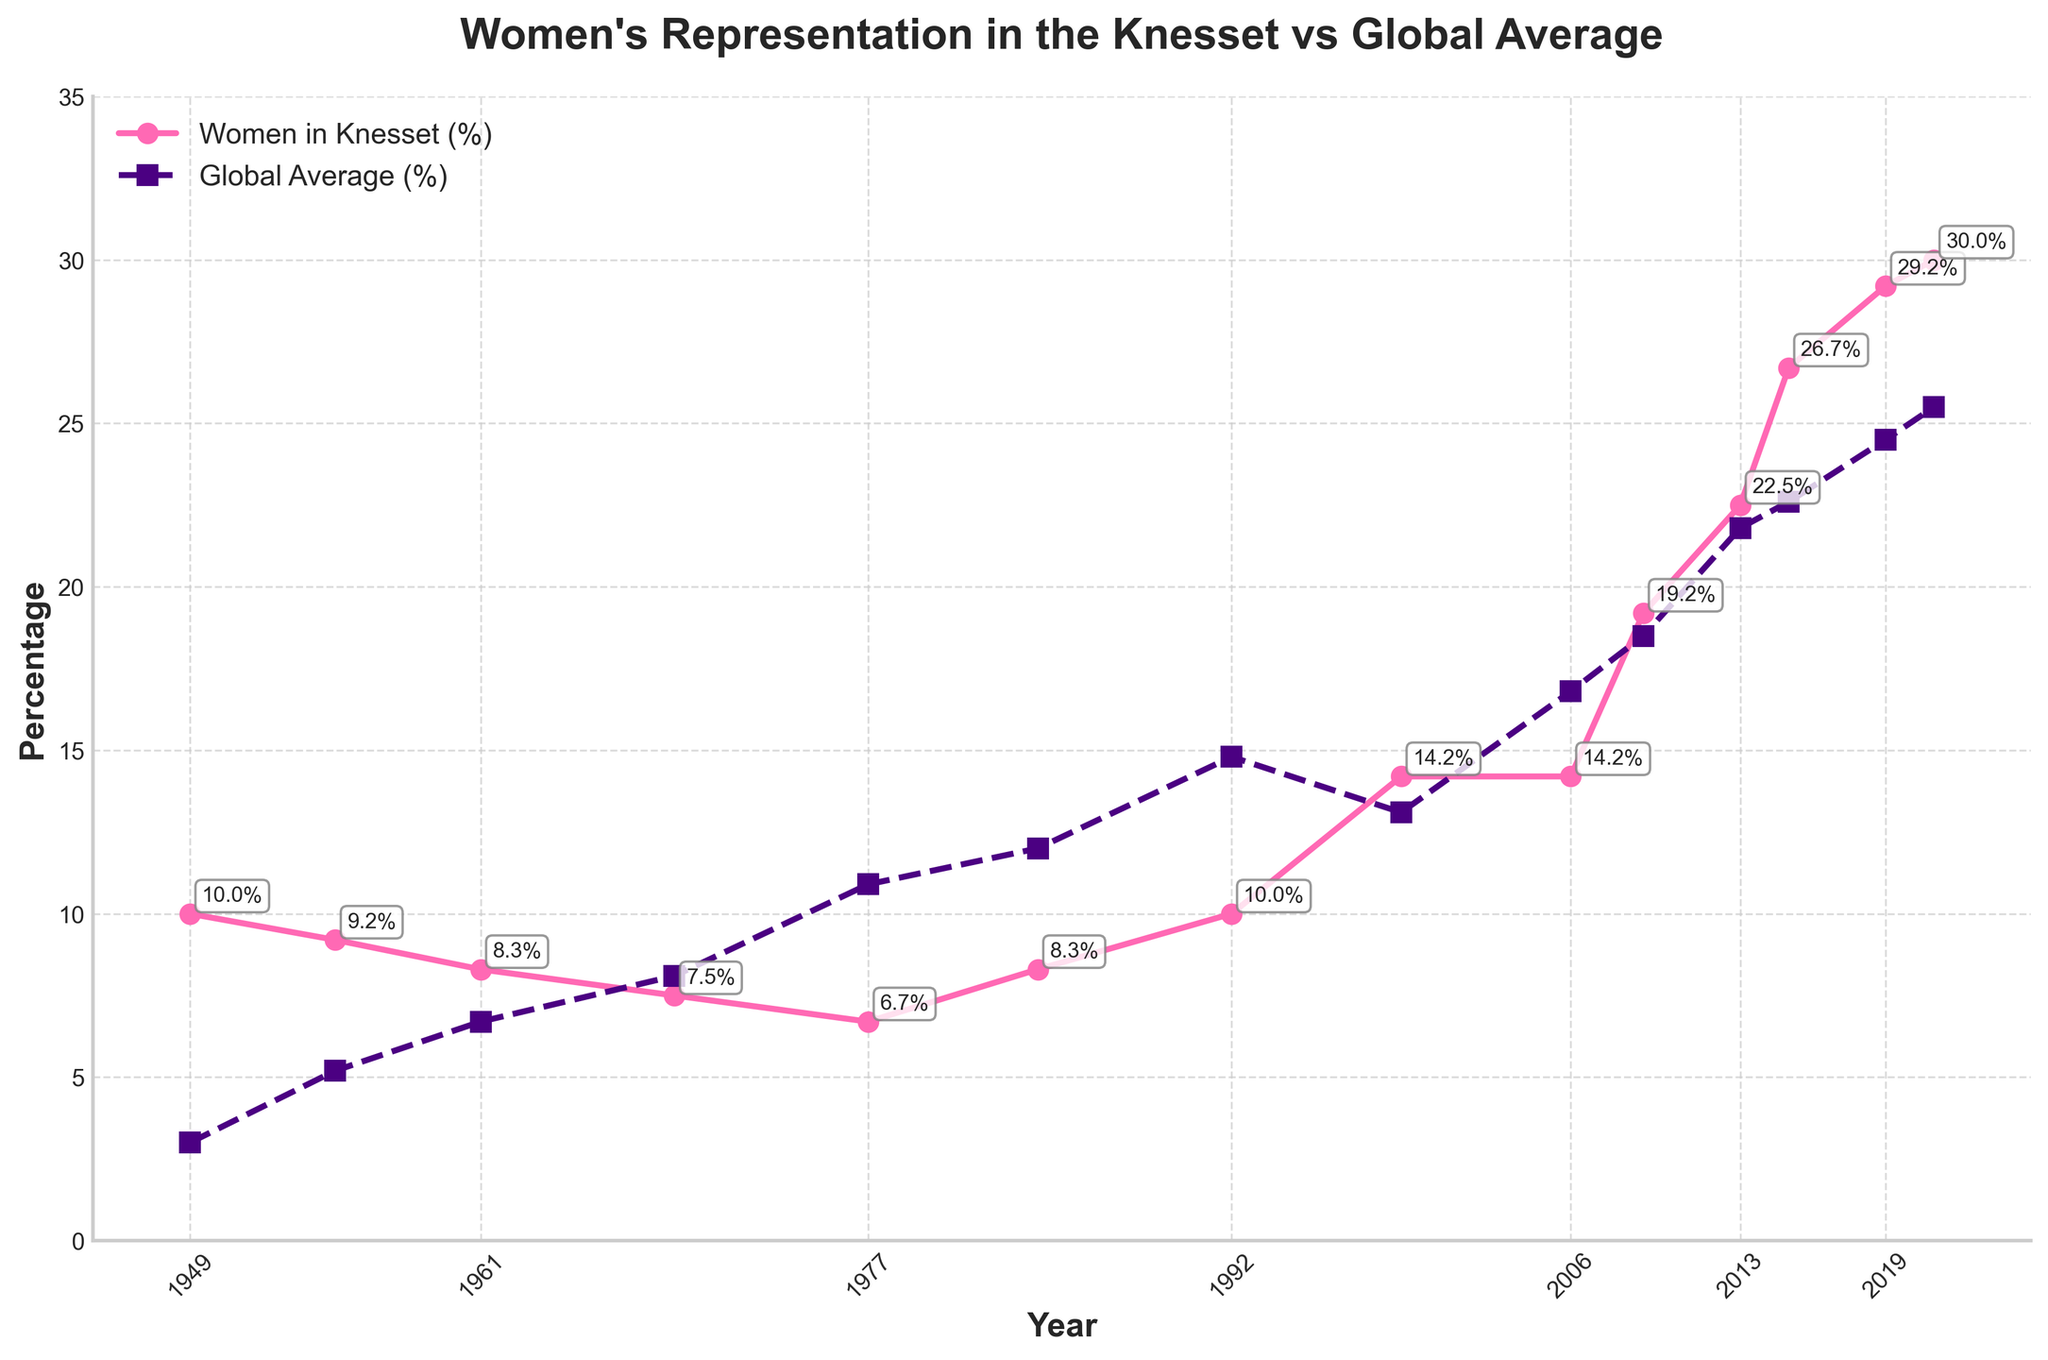What is the percentage of women in the Knesset in 1999? Refer to the data points for the year 1999 marked on the line chart for 'Women in Knesset (%)'. The annotated value shows the percentage.
Answer: 14.2% Is the percentage of women in the Knesset higher or lower than the global average in 2006? Compare the 'Women in Knesset (%)' and 'Global Average (%)' values for the year 2006. The chart shows that the percentage for the Knesset is equal to the global average.
Answer: Equal By how much did the representation of women in the Knesset increase from 2009 to 2015? Check the values for 2009 and 2015 on the 'Women in Knesset (%)' line. The increase is calculated as 26.7% (2015) - 19.2% (2009).
Answer: 7.5% What is the trend in the global average representation of women from 1949 to 2021? Observe the 'Global Average (%)' line from 1949 to 2021, noting if it generally increases, decreases, or remains constant. The line shows a generally increasing trend.
Answer: Increasing Which year had the lowest percentage of women representation in the Knesset and what was the percentage? Identify the lowest point of the 'Women in Knesset (%)' line. The lowest percentage occurs in 1977.
Answer: 6.7% How does women's representation in the Knesset in 2013 compare to the global average in the same year? Compare the 2013 values for 'Women in Knesset (%)' and 'Global Average (%)'. The Knesset percentage is higher than the global average.
Answer: Higher What was the percentage difference between women’s representation in the Knesset and the global average in 1977? Calculate the difference between the 'Women in Knesset (%)' and 'Global Average (%)' for 1977. The values are 6.7% (Knesset) and 10.9% (Global). Subtract 6.7 from 10.9.
Answer: -4.2% What can be inferred about the trajectory of women's representation in the Knesset compared to the global average over the years? Analyze both lines from the beginning to the end of the timeline. Note the relative positions and trends of 'Women in Knesset (%)' compared to 'Global Average (%)' over time. Initially, the Knesset had higher values than the global average, but while both increased, the global average surpassed the Knesset in the mid-to-late 20th century.
Answer: Fluctuating relationship Overall, did the percentage of women in the Knesset exceed the global average more often or less often throughout the years? Analyze how many times the 'Women in Knesset (%)' line is above or below the 'Global Average (%)' line. Count the instances where one exceeds or is less than the other.
Answer: Less often 